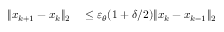<formula> <loc_0><loc_0><loc_500><loc_500>\begin{array} { r l } { \| x _ { k + 1 } - x _ { k } \| _ { 2 } } & \leq \varepsilon _ { \theta } ( 1 + \delta / 2 ) \| x _ { k } - x _ { k - 1 } \| _ { 2 } } \end{array}</formula> 